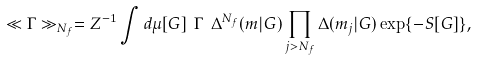<formula> <loc_0><loc_0><loc_500><loc_500>\ll \Gamma \gg _ { N _ { f } } = Z ^ { - 1 } \int d \mu [ G ] \ \Gamma \ \Delta ^ { N _ { f } } ( m | G ) \prod _ { j > N _ { f } } \Delta ( m _ { j } | G ) \exp \{ - S [ G ] \} ,</formula> 